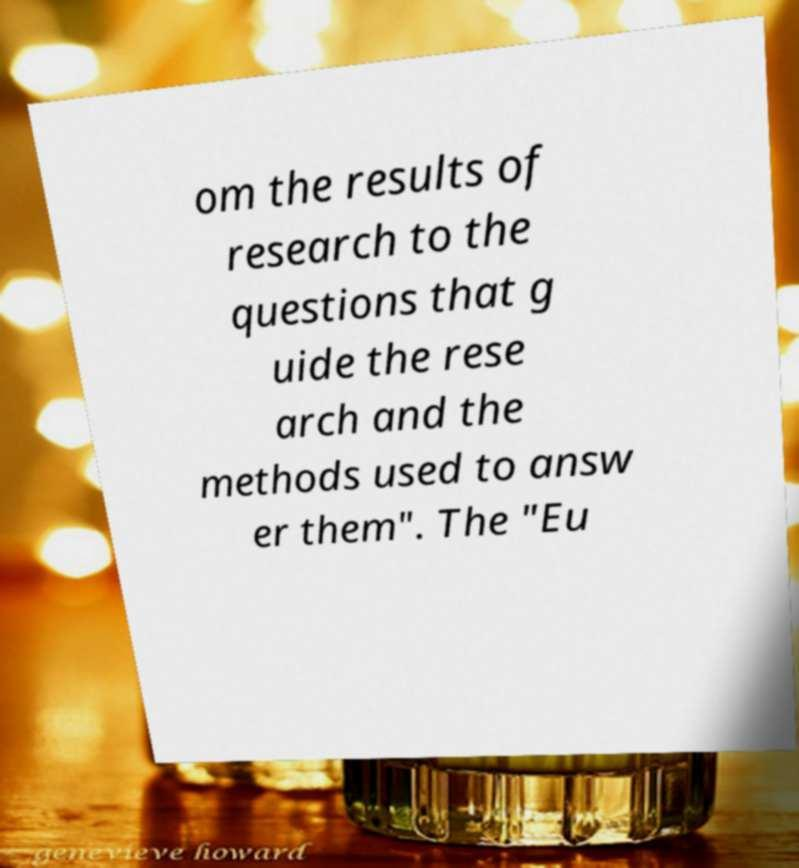Please identify and transcribe the text found in this image. om the results of research to the questions that g uide the rese arch and the methods used to answ er them". The "Eu 